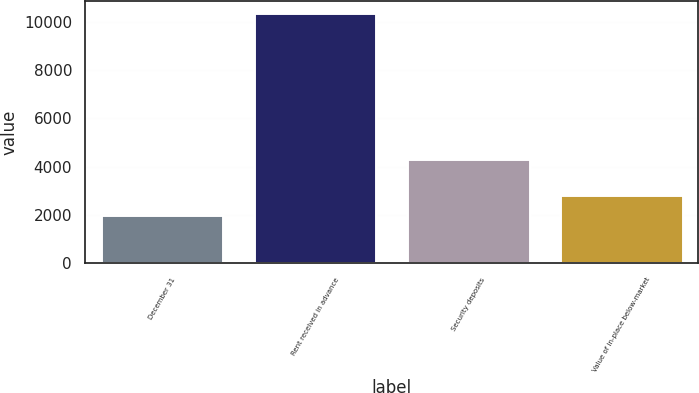Convert chart to OTSL. <chart><loc_0><loc_0><loc_500><loc_500><bar_chart><fcel>December 31<fcel>Rent received in advance<fcel>Security deposits<fcel>Value of in-place below-market<nl><fcel>2009<fcel>10341<fcel>4334<fcel>2842.2<nl></chart> 